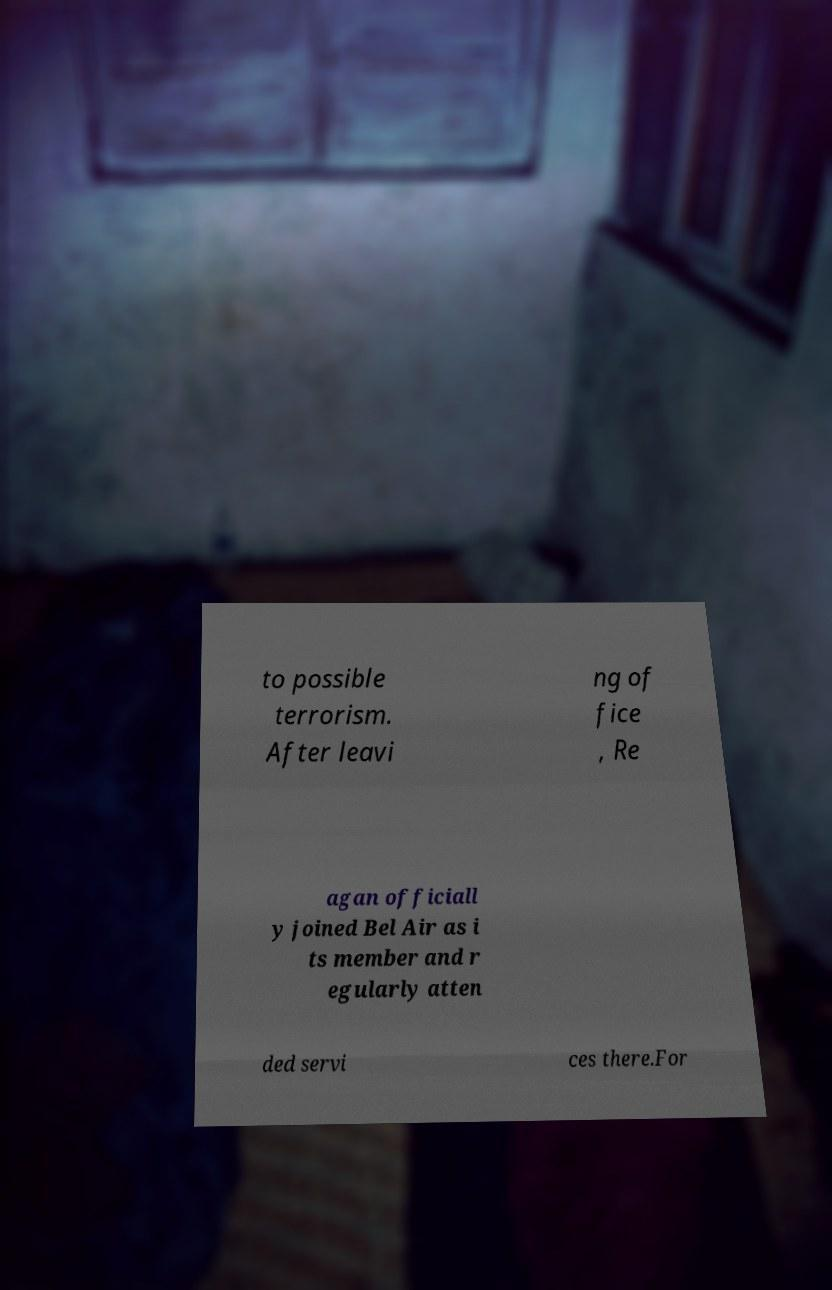Can you accurately transcribe the text from the provided image for me? to possible terrorism. After leavi ng of fice , Re agan officiall y joined Bel Air as i ts member and r egularly atten ded servi ces there.For 